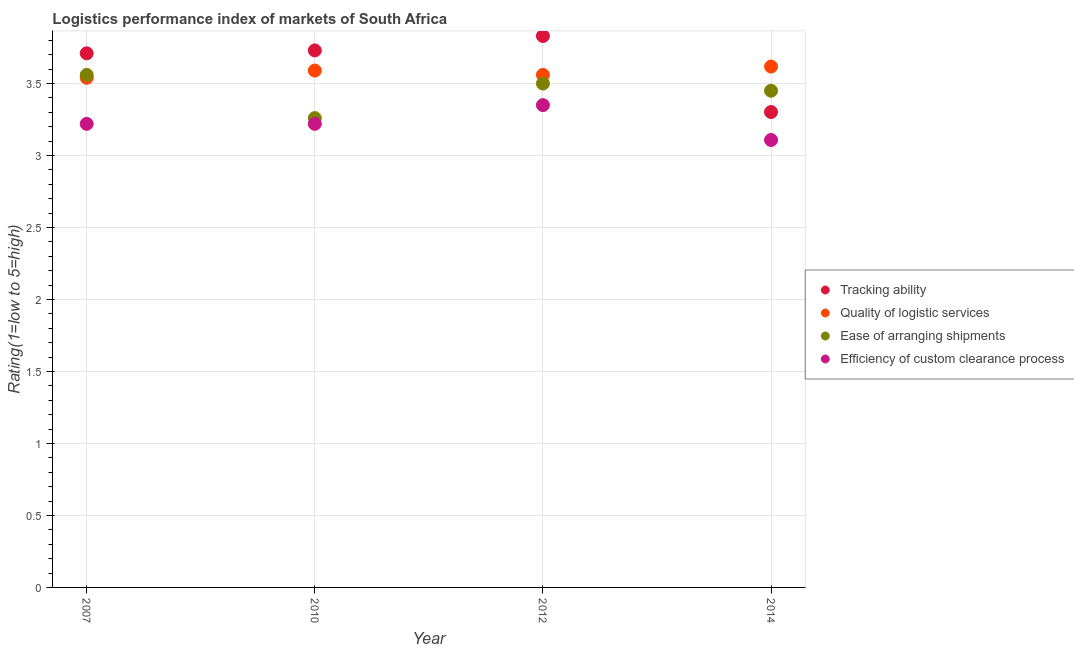Is the number of dotlines equal to the number of legend labels?
Offer a very short reply. Yes. What is the lpi rating of quality of logistic services in 2012?
Ensure brevity in your answer.  3.56. Across all years, what is the maximum lpi rating of tracking ability?
Make the answer very short. 3.83. Across all years, what is the minimum lpi rating of ease of arranging shipments?
Your answer should be compact. 3.26. What is the total lpi rating of efficiency of custom clearance process in the graph?
Provide a succinct answer. 12.9. What is the difference between the lpi rating of ease of arranging shipments in 2007 and that in 2010?
Your answer should be very brief. 0.3. What is the difference between the lpi rating of ease of arranging shipments in 2007 and the lpi rating of quality of logistic services in 2014?
Give a very brief answer. -0.06. What is the average lpi rating of ease of arranging shipments per year?
Ensure brevity in your answer.  3.44. In the year 2010, what is the difference between the lpi rating of efficiency of custom clearance process and lpi rating of tracking ability?
Provide a short and direct response. -0.51. In how many years, is the lpi rating of ease of arranging shipments greater than 3.1?
Provide a succinct answer. 4. What is the ratio of the lpi rating of ease of arranging shipments in 2007 to that in 2014?
Give a very brief answer. 1.03. Is the lpi rating of quality of logistic services in 2010 less than that in 2012?
Make the answer very short. No. What is the difference between the highest and the second highest lpi rating of ease of arranging shipments?
Provide a short and direct response. 0.06. What is the difference between the highest and the lowest lpi rating of efficiency of custom clearance process?
Your response must be concise. 0.24. Is the sum of the lpi rating of tracking ability in 2012 and 2014 greater than the maximum lpi rating of quality of logistic services across all years?
Your answer should be very brief. Yes. Is the lpi rating of tracking ability strictly greater than the lpi rating of quality of logistic services over the years?
Give a very brief answer. No. What is the difference between two consecutive major ticks on the Y-axis?
Offer a very short reply. 0.5. Does the graph contain any zero values?
Give a very brief answer. No. Does the graph contain grids?
Make the answer very short. Yes. Where does the legend appear in the graph?
Your answer should be compact. Center right. How many legend labels are there?
Ensure brevity in your answer.  4. How are the legend labels stacked?
Offer a very short reply. Vertical. What is the title of the graph?
Offer a very short reply. Logistics performance index of markets of South Africa. What is the label or title of the X-axis?
Your response must be concise. Year. What is the label or title of the Y-axis?
Give a very brief answer. Rating(1=low to 5=high). What is the Rating(1=low to 5=high) in Tracking ability in 2007?
Your response must be concise. 3.71. What is the Rating(1=low to 5=high) of Quality of logistic services in 2007?
Keep it short and to the point. 3.54. What is the Rating(1=low to 5=high) in Ease of arranging shipments in 2007?
Make the answer very short. 3.56. What is the Rating(1=low to 5=high) in Efficiency of custom clearance process in 2007?
Your answer should be very brief. 3.22. What is the Rating(1=low to 5=high) of Tracking ability in 2010?
Ensure brevity in your answer.  3.73. What is the Rating(1=low to 5=high) of Quality of logistic services in 2010?
Offer a terse response. 3.59. What is the Rating(1=low to 5=high) in Ease of arranging shipments in 2010?
Provide a short and direct response. 3.26. What is the Rating(1=low to 5=high) of Efficiency of custom clearance process in 2010?
Offer a very short reply. 3.22. What is the Rating(1=low to 5=high) in Tracking ability in 2012?
Your response must be concise. 3.83. What is the Rating(1=low to 5=high) of Quality of logistic services in 2012?
Provide a short and direct response. 3.56. What is the Rating(1=low to 5=high) in Ease of arranging shipments in 2012?
Provide a short and direct response. 3.5. What is the Rating(1=low to 5=high) of Efficiency of custom clearance process in 2012?
Provide a succinct answer. 3.35. What is the Rating(1=low to 5=high) of Tracking ability in 2014?
Keep it short and to the point. 3.3. What is the Rating(1=low to 5=high) of Quality of logistic services in 2014?
Your answer should be very brief. 3.62. What is the Rating(1=low to 5=high) in Ease of arranging shipments in 2014?
Ensure brevity in your answer.  3.45. What is the Rating(1=low to 5=high) in Efficiency of custom clearance process in 2014?
Ensure brevity in your answer.  3.11. Across all years, what is the maximum Rating(1=low to 5=high) of Tracking ability?
Your response must be concise. 3.83. Across all years, what is the maximum Rating(1=low to 5=high) in Quality of logistic services?
Your response must be concise. 3.62. Across all years, what is the maximum Rating(1=low to 5=high) in Ease of arranging shipments?
Offer a very short reply. 3.56. Across all years, what is the maximum Rating(1=low to 5=high) in Efficiency of custom clearance process?
Keep it short and to the point. 3.35. Across all years, what is the minimum Rating(1=low to 5=high) of Tracking ability?
Your answer should be very brief. 3.3. Across all years, what is the minimum Rating(1=low to 5=high) in Quality of logistic services?
Provide a succinct answer. 3.54. Across all years, what is the minimum Rating(1=low to 5=high) of Ease of arranging shipments?
Provide a short and direct response. 3.26. Across all years, what is the minimum Rating(1=low to 5=high) of Efficiency of custom clearance process?
Your answer should be very brief. 3.11. What is the total Rating(1=low to 5=high) of Tracking ability in the graph?
Make the answer very short. 14.57. What is the total Rating(1=low to 5=high) of Quality of logistic services in the graph?
Provide a succinct answer. 14.31. What is the total Rating(1=low to 5=high) of Ease of arranging shipments in the graph?
Keep it short and to the point. 13.77. What is the total Rating(1=low to 5=high) in Efficiency of custom clearance process in the graph?
Give a very brief answer. 12.9. What is the difference between the Rating(1=low to 5=high) in Tracking ability in 2007 and that in 2010?
Provide a succinct answer. -0.02. What is the difference between the Rating(1=low to 5=high) in Ease of arranging shipments in 2007 and that in 2010?
Make the answer very short. 0.3. What is the difference between the Rating(1=low to 5=high) in Efficiency of custom clearance process in 2007 and that in 2010?
Ensure brevity in your answer.  0. What is the difference between the Rating(1=low to 5=high) in Tracking ability in 2007 and that in 2012?
Your response must be concise. -0.12. What is the difference between the Rating(1=low to 5=high) in Quality of logistic services in 2007 and that in 2012?
Keep it short and to the point. -0.02. What is the difference between the Rating(1=low to 5=high) in Ease of arranging shipments in 2007 and that in 2012?
Give a very brief answer. 0.06. What is the difference between the Rating(1=low to 5=high) of Efficiency of custom clearance process in 2007 and that in 2012?
Offer a terse response. -0.13. What is the difference between the Rating(1=low to 5=high) in Tracking ability in 2007 and that in 2014?
Give a very brief answer. 0.41. What is the difference between the Rating(1=low to 5=high) of Quality of logistic services in 2007 and that in 2014?
Your answer should be compact. -0.08. What is the difference between the Rating(1=low to 5=high) in Ease of arranging shipments in 2007 and that in 2014?
Ensure brevity in your answer.  0.11. What is the difference between the Rating(1=low to 5=high) in Efficiency of custom clearance process in 2007 and that in 2014?
Make the answer very short. 0.11. What is the difference between the Rating(1=low to 5=high) of Tracking ability in 2010 and that in 2012?
Your response must be concise. -0.1. What is the difference between the Rating(1=low to 5=high) of Ease of arranging shipments in 2010 and that in 2012?
Your answer should be very brief. -0.24. What is the difference between the Rating(1=low to 5=high) of Efficiency of custom clearance process in 2010 and that in 2012?
Your answer should be compact. -0.13. What is the difference between the Rating(1=low to 5=high) in Tracking ability in 2010 and that in 2014?
Make the answer very short. 0.43. What is the difference between the Rating(1=low to 5=high) in Quality of logistic services in 2010 and that in 2014?
Your response must be concise. -0.03. What is the difference between the Rating(1=low to 5=high) of Ease of arranging shipments in 2010 and that in 2014?
Provide a succinct answer. -0.19. What is the difference between the Rating(1=low to 5=high) of Efficiency of custom clearance process in 2010 and that in 2014?
Your answer should be compact. 0.11. What is the difference between the Rating(1=low to 5=high) in Tracking ability in 2012 and that in 2014?
Provide a succinct answer. 0.53. What is the difference between the Rating(1=low to 5=high) of Quality of logistic services in 2012 and that in 2014?
Your response must be concise. -0.06. What is the difference between the Rating(1=low to 5=high) of Efficiency of custom clearance process in 2012 and that in 2014?
Your answer should be very brief. 0.24. What is the difference between the Rating(1=low to 5=high) of Tracking ability in 2007 and the Rating(1=low to 5=high) of Quality of logistic services in 2010?
Provide a succinct answer. 0.12. What is the difference between the Rating(1=low to 5=high) in Tracking ability in 2007 and the Rating(1=low to 5=high) in Ease of arranging shipments in 2010?
Give a very brief answer. 0.45. What is the difference between the Rating(1=low to 5=high) in Tracking ability in 2007 and the Rating(1=low to 5=high) in Efficiency of custom clearance process in 2010?
Offer a very short reply. 0.49. What is the difference between the Rating(1=low to 5=high) of Quality of logistic services in 2007 and the Rating(1=low to 5=high) of Ease of arranging shipments in 2010?
Offer a very short reply. 0.28. What is the difference between the Rating(1=low to 5=high) of Quality of logistic services in 2007 and the Rating(1=low to 5=high) of Efficiency of custom clearance process in 2010?
Your answer should be compact. 0.32. What is the difference between the Rating(1=low to 5=high) of Ease of arranging shipments in 2007 and the Rating(1=low to 5=high) of Efficiency of custom clearance process in 2010?
Make the answer very short. 0.34. What is the difference between the Rating(1=low to 5=high) in Tracking ability in 2007 and the Rating(1=low to 5=high) in Quality of logistic services in 2012?
Offer a terse response. 0.15. What is the difference between the Rating(1=low to 5=high) of Tracking ability in 2007 and the Rating(1=low to 5=high) of Ease of arranging shipments in 2012?
Your answer should be very brief. 0.21. What is the difference between the Rating(1=low to 5=high) of Tracking ability in 2007 and the Rating(1=low to 5=high) of Efficiency of custom clearance process in 2012?
Your answer should be very brief. 0.36. What is the difference between the Rating(1=low to 5=high) in Quality of logistic services in 2007 and the Rating(1=low to 5=high) in Efficiency of custom clearance process in 2012?
Provide a short and direct response. 0.19. What is the difference between the Rating(1=low to 5=high) of Ease of arranging shipments in 2007 and the Rating(1=low to 5=high) of Efficiency of custom clearance process in 2012?
Your answer should be very brief. 0.21. What is the difference between the Rating(1=low to 5=high) in Tracking ability in 2007 and the Rating(1=low to 5=high) in Quality of logistic services in 2014?
Your answer should be compact. 0.09. What is the difference between the Rating(1=low to 5=high) of Tracking ability in 2007 and the Rating(1=low to 5=high) of Ease of arranging shipments in 2014?
Keep it short and to the point. 0.26. What is the difference between the Rating(1=low to 5=high) of Tracking ability in 2007 and the Rating(1=low to 5=high) of Efficiency of custom clearance process in 2014?
Offer a terse response. 0.6. What is the difference between the Rating(1=low to 5=high) of Quality of logistic services in 2007 and the Rating(1=low to 5=high) of Ease of arranging shipments in 2014?
Keep it short and to the point. 0.09. What is the difference between the Rating(1=low to 5=high) of Quality of logistic services in 2007 and the Rating(1=low to 5=high) of Efficiency of custom clearance process in 2014?
Offer a very short reply. 0.43. What is the difference between the Rating(1=low to 5=high) in Ease of arranging shipments in 2007 and the Rating(1=low to 5=high) in Efficiency of custom clearance process in 2014?
Offer a very short reply. 0.45. What is the difference between the Rating(1=low to 5=high) in Tracking ability in 2010 and the Rating(1=low to 5=high) in Quality of logistic services in 2012?
Make the answer very short. 0.17. What is the difference between the Rating(1=low to 5=high) in Tracking ability in 2010 and the Rating(1=low to 5=high) in Ease of arranging shipments in 2012?
Your response must be concise. 0.23. What is the difference between the Rating(1=low to 5=high) of Tracking ability in 2010 and the Rating(1=low to 5=high) of Efficiency of custom clearance process in 2012?
Offer a very short reply. 0.38. What is the difference between the Rating(1=low to 5=high) in Quality of logistic services in 2010 and the Rating(1=low to 5=high) in Ease of arranging shipments in 2012?
Offer a very short reply. 0.09. What is the difference between the Rating(1=low to 5=high) of Quality of logistic services in 2010 and the Rating(1=low to 5=high) of Efficiency of custom clearance process in 2012?
Your response must be concise. 0.24. What is the difference between the Rating(1=low to 5=high) of Ease of arranging shipments in 2010 and the Rating(1=low to 5=high) of Efficiency of custom clearance process in 2012?
Your answer should be compact. -0.09. What is the difference between the Rating(1=low to 5=high) in Tracking ability in 2010 and the Rating(1=low to 5=high) in Quality of logistic services in 2014?
Your answer should be compact. 0.11. What is the difference between the Rating(1=low to 5=high) in Tracking ability in 2010 and the Rating(1=low to 5=high) in Ease of arranging shipments in 2014?
Give a very brief answer. 0.28. What is the difference between the Rating(1=low to 5=high) in Tracking ability in 2010 and the Rating(1=low to 5=high) in Efficiency of custom clearance process in 2014?
Your response must be concise. 0.62. What is the difference between the Rating(1=low to 5=high) in Quality of logistic services in 2010 and the Rating(1=low to 5=high) in Ease of arranging shipments in 2014?
Provide a short and direct response. 0.14. What is the difference between the Rating(1=low to 5=high) of Quality of logistic services in 2010 and the Rating(1=low to 5=high) of Efficiency of custom clearance process in 2014?
Offer a very short reply. 0.48. What is the difference between the Rating(1=low to 5=high) of Ease of arranging shipments in 2010 and the Rating(1=low to 5=high) of Efficiency of custom clearance process in 2014?
Your answer should be compact. 0.15. What is the difference between the Rating(1=low to 5=high) in Tracking ability in 2012 and the Rating(1=low to 5=high) in Quality of logistic services in 2014?
Make the answer very short. 0.21. What is the difference between the Rating(1=low to 5=high) in Tracking ability in 2012 and the Rating(1=low to 5=high) in Ease of arranging shipments in 2014?
Offer a terse response. 0.38. What is the difference between the Rating(1=low to 5=high) in Tracking ability in 2012 and the Rating(1=low to 5=high) in Efficiency of custom clearance process in 2014?
Make the answer very short. 0.72. What is the difference between the Rating(1=low to 5=high) in Quality of logistic services in 2012 and the Rating(1=low to 5=high) in Ease of arranging shipments in 2014?
Provide a succinct answer. 0.11. What is the difference between the Rating(1=low to 5=high) of Quality of logistic services in 2012 and the Rating(1=low to 5=high) of Efficiency of custom clearance process in 2014?
Provide a succinct answer. 0.45. What is the difference between the Rating(1=low to 5=high) in Ease of arranging shipments in 2012 and the Rating(1=low to 5=high) in Efficiency of custom clearance process in 2014?
Keep it short and to the point. 0.39. What is the average Rating(1=low to 5=high) in Tracking ability per year?
Your answer should be compact. 3.64. What is the average Rating(1=low to 5=high) in Quality of logistic services per year?
Offer a terse response. 3.58. What is the average Rating(1=low to 5=high) of Ease of arranging shipments per year?
Give a very brief answer. 3.44. What is the average Rating(1=low to 5=high) in Efficiency of custom clearance process per year?
Your answer should be compact. 3.22. In the year 2007, what is the difference between the Rating(1=low to 5=high) in Tracking ability and Rating(1=low to 5=high) in Quality of logistic services?
Your answer should be very brief. 0.17. In the year 2007, what is the difference between the Rating(1=low to 5=high) of Tracking ability and Rating(1=low to 5=high) of Ease of arranging shipments?
Offer a terse response. 0.15. In the year 2007, what is the difference between the Rating(1=low to 5=high) in Tracking ability and Rating(1=low to 5=high) in Efficiency of custom clearance process?
Ensure brevity in your answer.  0.49. In the year 2007, what is the difference between the Rating(1=low to 5=high) of Quality of logistic services and Rating(1=low to 5=high) of Ease of arranging shipments?
Provide a succinct answer. -0.02. In the year 2007, what is the difference between the Rating(1=low to 5=high) in Quality of logistic services and Rating(1=low to 5=high) in Efficiency of custom clearance process?
Your response must be concise. 0.32. In the year 2007, what is the difference between the Rating(1=low to 5=high) in Ease of arranging shipments and Rating(1=low to 5=high) in Efficiency of custom clearance process?
Your response must be concise. 0.34. In the year 2010, what is the difference between the Rating(1=low to 5=high) in Tracking ability and Rating(1=low to 5=high) in Quality of logistic services?
Your response must be concise. 0.14. In the year 2010, what is the difference between the Rating(1=low to 5=high) of Tracking ability and Rating(1=low to 5=high) of Ease of arranging shipments?
Offer a terse response. 0.47. In the year 2010, what is the difference between the Rating(1=low to 5=high) of Tracking ability and Rating(1=low to 5=high) of Efficiency of custom clearance process?
Provide a short and direct response. 0.51. In the year 2010, what is the difference between the Rating(1=low to 5=high) in Quality of logistic services and Rating(1=low to 5=high) in Ease of arranging shipments?
Ensure brevity in your answer.  0.33. In the year 2010, what is the difference between the Rating(1=low to 5=high) in Quality of logistic services and Rating(1=low to 5=high) in Efficiency of custom clearance process?
Give a very brief answer. 0.37. In the year 2010, what is the difference between the Rating(1=low to 5=high) in Ease of arranging shipments and Rating(1=low to 5=high) in Efficiency of custom clearance process?
Give a very brief answer. 0.04. In the year 2012, what is the difference between the Rating(1=low to 5=high) in Tracking ability and Rating(1=low to 5=high) in Quality of logistic services?
Your answer should be compact. 0.27. In the year 2012, what is the difference between the Rating(1=low to 5=high) in Tracking ability and Rating(1=low to 5=high) in Ease of arranging shipments?
Offer a terse response. 0.33. In the year 2012, what is the difference between the Rating(1=low to 5=high) of Tracking ability and Rating(1=low to 5=high) of Efficiency of custom clearance process?
Give a very brief answer. 0.48. In the year 2012, what is the difference between the Rating(1=low to 5=high) in Quality of logistic services and Rating(1=low to 5=high) in Efficiency of custom clearance process?
Your response must be concise. 0.21. In the year 2014, what is the difference between the Rating(1=low to 5=high) of Tracking ability and Rating(1=low to 5=high) of Quality of logistic services?
Provide a succinct answer. -0.32. In the year 2014, what is the difference between the Rating(1=low to 5=high) in Tracking ability and Rating(1=low to 5=high) in Ease of arranging shipments?
Offer a terse response. -0.15. In the year 2014, what is the difference between the Rating(1=low to 5=high) of Tracking ability and Rating(1=low to 5=high) of Efficiency of custom clearance process?
Your answer should be compact. 0.19. In the year 2014, what is the difference between the Rating(1=low to 5=high) of Quality of logistic services and Rating(1=low to 5=high) of Ease of arranging shipments?
Your answer should be very brief. 0.17. In the year 2014, what is the difference between the Rating(1=low to 5=high) in Quality of logistic services and Rating(1=low to 5=high) in Efficiency of custom clearance process?
Provide a short and direct response. 0.51. In the year 2014, what is the difference between the Rating(1=low to 5=high) of Ease of arranging shipments and Rating(1=low to 5=high) of Efficiency of custom clearance process?
Provide a succinct answer. 0.34. What is the ratio of the Rating(1=low to 5=high) in Tracking ability in 2007 to that in 2010?
Offer a terse response. 0.99. What is the ratio of the Rating(1=low to 5=high) of Quality of logistic services in 2007 to that in 2010?
Provide a succinct answer. 0.99. What is the ratio of the Rating(1=low to 5=high) in Ease of arranging shipments in 2007 to that in 2010?
Your answer should be very brief. 1.09. What is the ratio of the Rating(1=low to 5=high) of Efficiency of custom clearance process in 2007 to that in 2010?
Provide a short and direct response. 1. What is the ratio of the Rating(1=low to 5=high) in Tracking ability in 2007 to that in 2012?
Your answer should be very brief. 0.97. What is the ratio of the Rating(1=low to 5=high) in Ease of arranging shipments in 2007 to that in 2012?
Provide a short and direct response. 1.02. What is the ratio of the Rating(1=low to 5=high) of Efficiency of custom clearance process in 2007 to that in 2012?
Give a very brief answer. 0.96. What is the ratio of the Rating(1=low to 5=high) of Tracking ability in 2007 to that in 2014?
Give a very brief answer. 1.12. What is the ratio of the Rating(1=low to 5=high) in Quality of logistic services in 2007 to that in 2014?
Give a very brief answer. 0.98. What is the ratio of the Rating(1=low to 5=high) in Ease of arranging shipments in 2007 to that in 2014?
Give a very brief answer. 1.03. What is the ratio of the Rating(1=low to 5=high) in Efficiency of custom clearance process in 2007 to that in 2014?
Ensure brevity in your answer.  1.04. What is the ratio of the Rating(1=low to 5=high) of Tracking ability in 2010 to that in 2012?
Keep it short and to the point. 0.97. What is the ratio of the Rating(1=low to 5=high) in Quality of logistic services in 2010 to that in 2012?
Make the answer very short. 1.01. What is the ratio of the Rating(1=low to 5=high) in Ease of arranging shipments in 2010 to that in 2012?
Provide a succinct answer. 0.93. What is the ratio of the Rating(1=low to 5=high) in Efficiency of custom clearance process in 2010 to that in 2012?
Offer a very short reply. 0.96. What is the ratio of the Rating(1=low to 5=high) of Tracking ability in 2010 to that in 2014?
Give a very brief answer. 1.13. What is the ratio of the Rating(1=low to 5=high) of Ease of arranging shipments in 2010 to that in 2014?
Provide a short and direct response. 0.94. What is the ratio of the Rating(1=low to 5=high) in Efficiency of custom clearance process in 2010 to that in 2014?
Give a very brief answer. 1.04. What is the ratio of the Rating(1=low to 5=high) in Tracking ability in 2012 to that in 2014?
Make the answer very short. 1.16. What is the ratio of the Rating(1=low to 5=high) in Quality of logistic services in 2012 to that in 2014?
Your answer should be compact. 0.98. What is the ratio of the Rating(1=low to 5=high) of Ease of arranging shipments in 2012 to that in 2014?
Make the answer very short. 1.01. What is the ratio of the Rating(1=low to 5=high) of Efficiency of custom clearance process in 2012 to that in 2014?
Your answer should be very brief. 1.08. What is the difference between the highest and the second highest Rating(1=low to 5=high) in Quality of logistic services?
Keep it short and to the point. 0.03. What is the difference between the highest and the second highest Rating(1=low to 5=high) in Efficiency of custom clearance process?
Offer a terse response. 0.13. What is the difference between the highest and the lowest Rating(1=low to 5=high) in Tracking ability?
Offer a very short reply. 0.53. What is the difference between the highest and the lowest Rating(1=low to 5=high) of Quality of logistic services?
Your answer should be very brief. 0.08. What is the difference between the highest and the lowest Rating(1=low to 5=high) in Efficiency of custom clearance process?
Your answer should be compact. 0.24. 